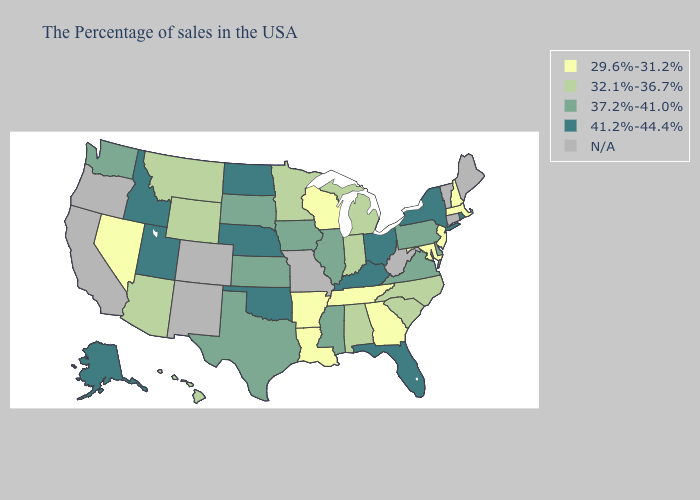How many symbols are there in the legend?
Short answer required. 5. Name the states that have a value in the range 41.2%-44.4%?
Keep it brief. Rhode Island, New York, Ohio, Florida, Kentucky, Nebraska, Oklahoma, North Dakota, Utah, Idaho, Alaska. What is the value of Hawaii?
Short answer required. 32.1%-36.7%. Among the states that border Georgia , does South Carolina have the lowest value?
Give a very brief answer. No. Name the states that have a value in the range 41.2%-44.4%?
Answer briefly. Rhode Island, New York, Ohio, Florida, Kentucky, Nebraska, Oklahoma, North Dakota, Utah, Idaho, Alaska. Which states have the lowest value in the USA?
Be succinct. Massachusetts, New Hampshire, New Jersey, Maryland, Georgia, Tennessee, Wisconsin, Louisiana, Arkansas, Nevada. Which states have the lowest value in the Northeast?
Quick response, please. Massachusetts, New Hampshire, New Jersey. Among the states that border Nebraska , does South Dakota have the lowest value?
Keep it brief. No. Among the states that border Virginia , which have the lowest value?
Answer briefly. Maryland, Tennessee. What is the lowest value in states that border Missouri?
Keep it brief. 29.6%-31.2%. What is the value of Florida?
Write a very short answer. 41.2%-44.4%. Name the states that have a value in the range 29.6%-31.2%?
Short answer required. Massachusetts, New Hampshire, New Jersey, Maryland, Georgia, Tennessee, Wisconsin, Louisiana, Arkansas, Nevada. Name the states that have a value in the range 37.2%-41.0%?
Be succinct. Delaware, Pennsylvania, Virginia, Illinois, Mississippi, Iowa, Kansas, Texas, South Dakota, Washington. Name the states that have a value in the range 41.2%-44.4%?
Concise answer only. Rhode Island, New York, Ohio, Florida, Kentucky, Nebraska, Oklahoma, North Dakota, Utah, Idaho, Alaska. Does Minnesota have the highest value in the MidWest?
Concise answer only. No. 